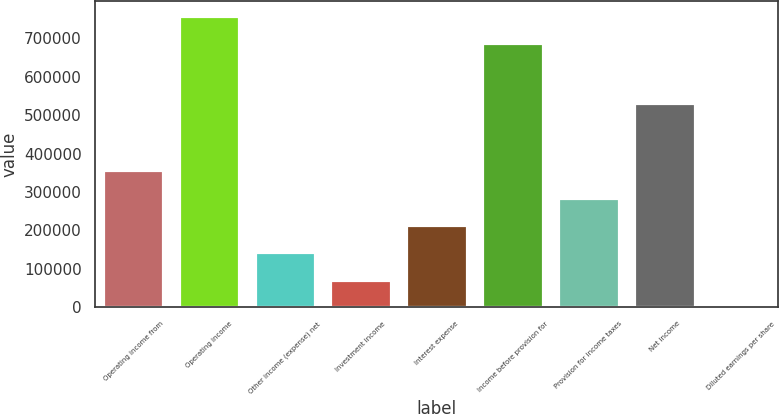Convert chart to OTSL. <chart><loc_0><loc_0><loc_500><loc_500><bar_chart><fcel>Operating income from<fcel>Operating income<fcel>Other income (expense) net<fcel>Investment income<fcel>Interest expense<fcel>Income before provision for<fcel>Provision for income taxes<fcel>Net income<fcel>Diluted earnings per share<nl><fcel>356763<fcel>757981<fcel>142707<fcel>71355.2<fcel>214059<fcel>686629<fcel>285411<fcel>531451<fcel>3.19<nl></chart> 